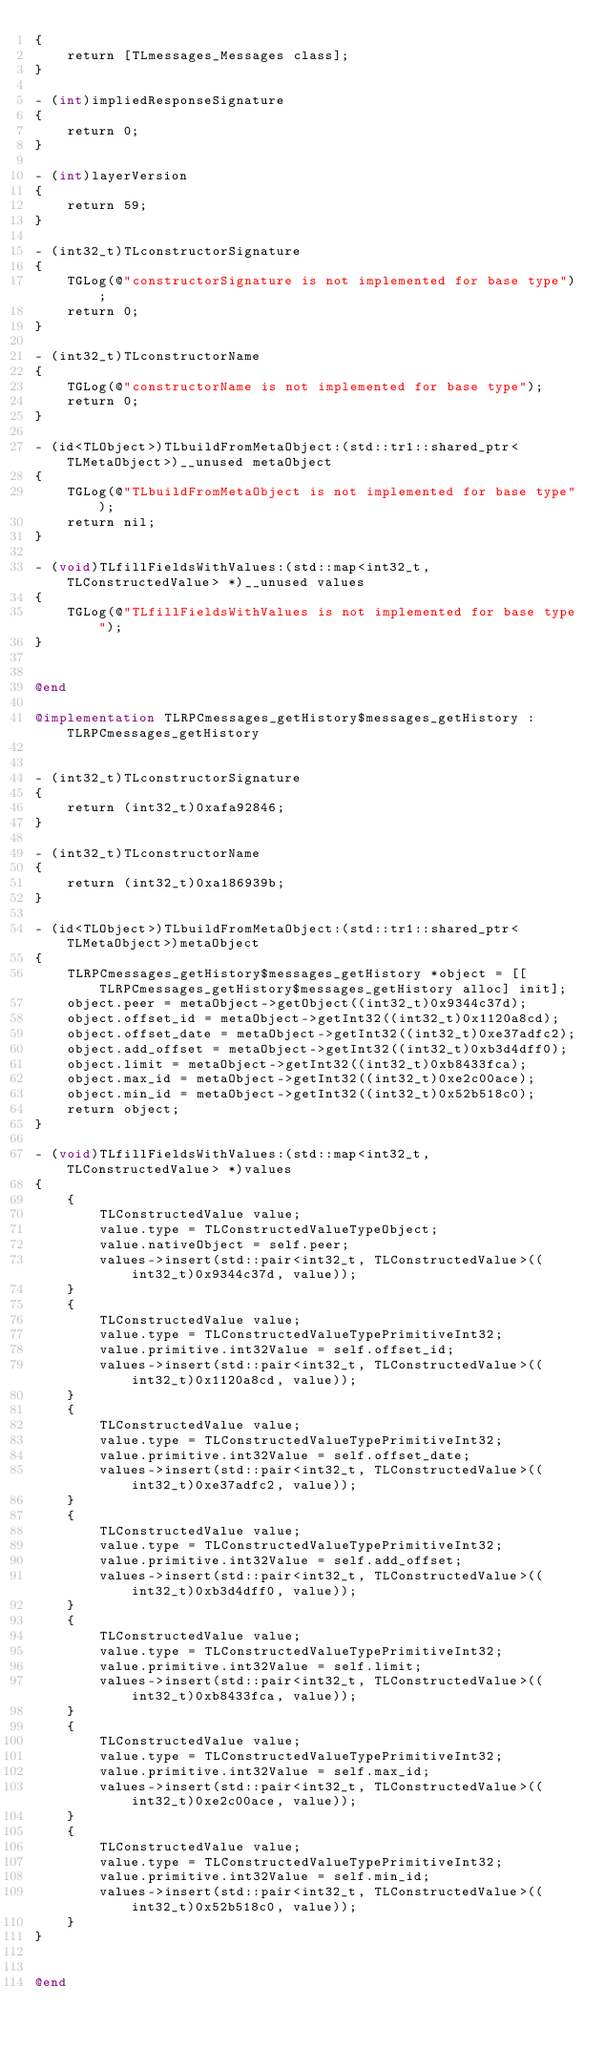Convert code to text. <code><loc_0><loc_0><loc_500><loc_500><_ObjectiveC_>{
    return [TLmessages_Messages class];
}

- (int)impliedResponseSignature
{
    return 0;
}

- (int)layerVersion
{
    return 59;
}

- (int32_t)TLconstructorSignature
{
    TGLog(@"constructorSignature is not implemented for base type");
    return 0;
}

- (int32_t)TLconstructorName
{
    TGLog(@"constructorName is not implemented for base type");
    return 0;
}

- (id<TLObject>)TLbuildFromMetaObject:(std::tr1::shared_ptr<TLMetaObject>)__unused metaObject
{
    TGLog(@"TLbuildFromMetaObject is not implemented for base type");
    return nil;
}

- (void)TLfillFieldsWithValues:(std::map<int32_t, TLConstructedValue> *)__unused values
{
    TGLog(@"TLfillFieldsWithValues is not implemented for base type");
}


@end

@implementation TLRPCmessages_getHistory$messages_getHistory : TLRPCmessages_getHistory


- (int32_t)TLconstructorSignature
{
    return (int32_t)0xafa92846;
}

- (int32_t)TLconstructorName
{
    return (int32_t)0xa186939b;
}

- (id<TLObject>)TLbuildFromMetaObject:(std::tr1::shared_ptr<TLMetaObject>)metaObject
{
    TLRPCmessages_getHistory$messages_getHistory *object = [[TLRPCmessages_getHistory$messages_getHistory alloc] init];
    object.peer = metaObject->getObject((int32_t)0x9344c37d);
    object.offset_id = metaObject->getInt32((int32_t)0x1120a8cd);
    object.offset_date = metaObject->getInt32((int32_t)0xe37adfc2);
    object.add_offset = metaObject->getInt32((int32_t)0xb3d4dff0);
    object.limit = metaObject->getInt32((int32_t)0xb8433fca);
    object.max_id = metaObject->getInt32((int32_t)0xe2c00ace);
    object.min_id = metaObject->getInt32((int32_t)0x52b518c0);
    return object;
}

- (void)TLfillFieldsWithValues:(std::map<int32_t, TLConstructedValue> *)values
{
    {
        TLConstructedValue value;
        value.type = TLConstructedValueTypeObject;
        value.nativeObject = self.peer;
        values->insert(std::pair<int32_t, TLConstructedValue>((int32_t)0x9344c37d, value));
    }
    {
        TLConstructedValue value;
        value.type = TLConstructedValueTypePrimitiveInt32;
        value.primitive.int32Value = self.offset_id;
        values->insert(std::pair<int32_t, TLConstructedValue>((int32_t)0x1120a8cd, value));
    }
    {
        TLConstructedValue value;
        value.type = TLConstructedValueTypePrimitiveInt32;
        value.primitive.int32Value = self.offset_date;
        values->insert(std::pair<int32_t, TLConstructedValue>((int32_t)0xe37adfc2, value));
    }
    {
        TLConstructedValue value;
        value.type = TLConstructedValueTypePrimitiveInt32;
        value.primitive.int32Value = self.add_offset;
        values->insert(std::pair<int32_t, TLConstructedValue>((int32_t)0xb3d4dff0, value));
    }
    {
        TLConstructedValue value;
        value.type = TLConstructedValueTypePrimitiveInt32;
        value.primitive.int32Value = self.limit;
        values->insert(std::pair<int32_t, TLConstructedValue>((int32_t)0xb8433fca, value));
    }
    {
        TLConstructedValue value;
        value.type = TLConstructedValueTypePrimitiveInt32;
        value.primitive.int32Value = self.max_id;
        values->insert(std::pair<int32_t, TLConstructedValue>((int32_t)0xe2c00ace, value));
    }
    {
        TLConstructedValue value;
        value.type = TLConstructedValueTypePrimitiveInt32;
        value.primitive.int32Value = self.min_id;
        values->insert(std::pair<int32_t, TLConstructedValue>((int32_t)0x52b518c0, value));
    }
}


@end

</code> 